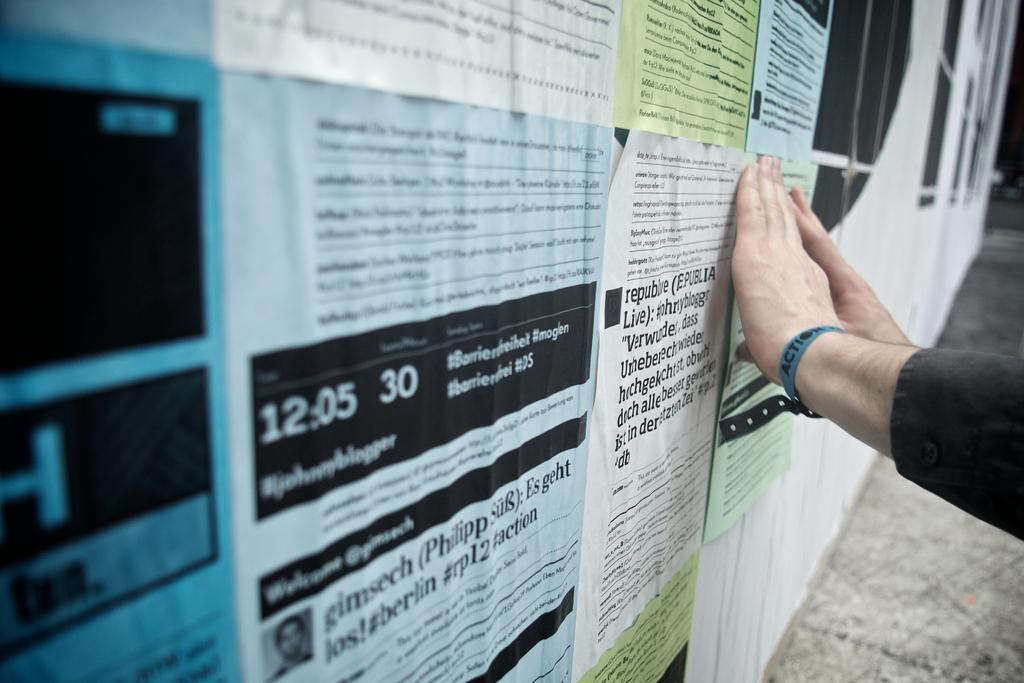<image>
Present a compact description of the photo's key features. A person wearing an Action bracelet puts up a sign written in German on a wall with other signs. 